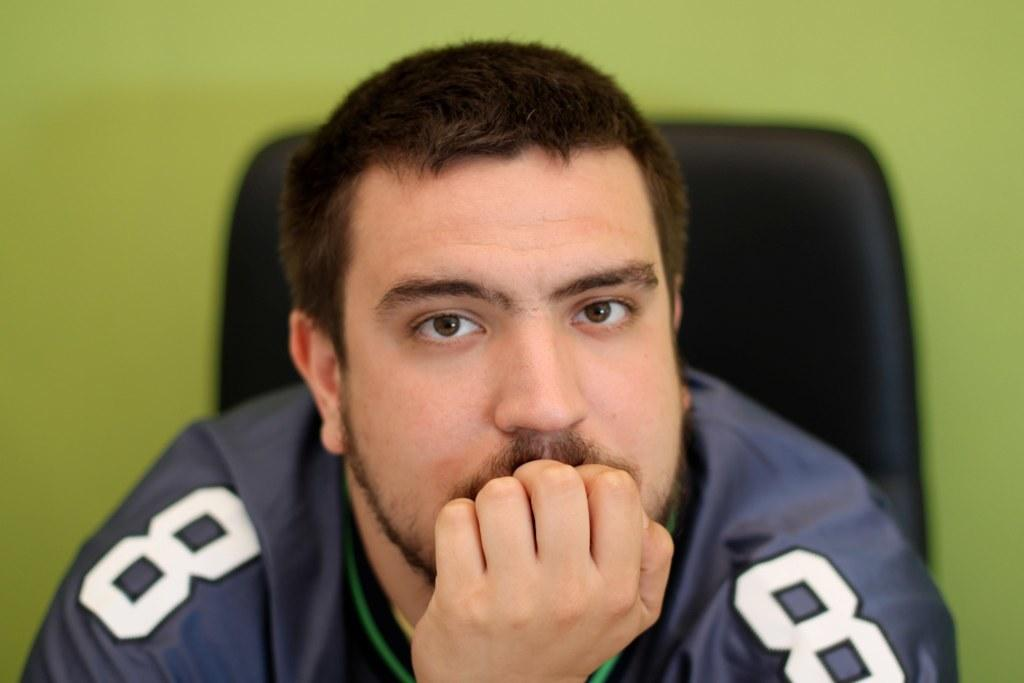<image>
Give a short and clear explanation of the subsequent image. A man wearing a sports shirt with the number eight on both of his shoulders. 